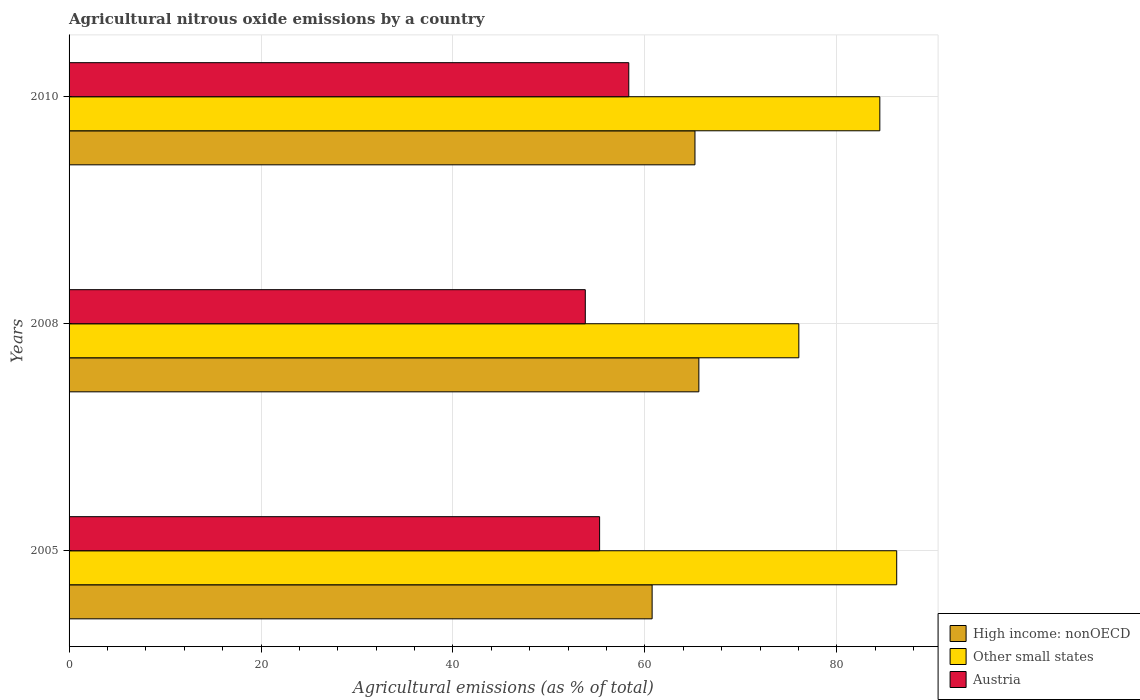How many different coloured bars are there?
Keep it short and to the point. 3. How many groups of bars are there?
Ensure brevity in your answer.  3. Are the number of bars per tick equal to the number of legend labels?
Your answer should be compact. Yes. How many bars are there on the 3rd tick from the top?
Ensure brevity in your answer.  3. How many bars are there on the 2nd tick from the bottom?
Give a very brief answer. 3. What is the label of the 3rd group of bars from the top?
Offer a terse response. 2005. In how many cases, is the number of bars for a given year not equal to the number of legend labels?
Give a very brief answer. 0. What is the amount of agricultural nitrous oxide emitted in Austria in 2008?
Keep it short and to the point. 53.8. Across all years, what is the maximum amount of agricultural nitrous oxide emitted in Other small states?
Your response must be concise. 86.25. Across all years, what is the minimum amount of agricultural nitrous oxide emitted in Austria?
Give a very brief answer. 53.8. In which year was the amount of agricultural nitrous oxide emitted in Other small states maximum?
Your response must be concise. 2005. In which year was the amount of agricultural nitrous oxide emitted in Austria minimum?
Your answer should be compact. 2008. What is the total amount of agricultural nitrous oxide emitted in High income: nonOECD in the graph?
Provide a short and direct response. 191.61. What is the difference between the amount of agricultural nitrous oxide emitted in Other small states in 2008 and that in 2010?
Offer a very short reply. -8.44. What is the difference between the amount of agricultural nitrous oxide emitted in Other small states in 2005 and the amount of agricultural nitrous oxide emitted in High income: nonOECD in 2008?
Offer a very short reply. 20.62. What is the average amount of agricultural nitrous oxide emitted in Austria per year?
Your answer should be very brief. 55.8. In the year 2005, what is the difference between the amount of agricultural nitrous oxide emitted in Austria and amount of agricultural nitrous oxide emitted in Other small states?
Provide a short and direct response. -30.96. In how many years, is the amount of agricultural nitrous oxide emitted in Other small states greater than 20 %?
Offer a terse response. 3. What is the ratio of the amount of agricultural nitrous oxide emitted in Other small states in 2005 to that in 2008?
Offer a very short reply. 1.13. Is the amount of agricultural nitrous oxide emitted in High income: nonOECD in 2008 less than that in 2010?
Offer a terse response. No. Is the difference between the amount of agricultural nitrous oxide emitted in Austria in 2005 and 2010 greater than the difference between the amount of agricultural nitrous oxide emitted in Other small states in 2005 and 2010?
Give a very brief answer. No. What is the difference between the highest and the second highest amount of agricultural nitrous oxide emitted in Other small states?
Keep it short and to the point. 1.76. What is the difference between the highest and the lowest amount of agricultural nitrous oxide emitted in Other small states?
Offer a terse response. 10.2. What does the 3rd bar from the top in 2005 represents?
Give a very brief answer. High income: nonOECD. What does the 2nd bar from the bottom in 2005 represents?
Give a very brief answer. Other small states. Is it the case that in every year, the sum of the amount of agricultural nitrous oxide emitted in Other small states and amount of agricultural nitrous oxide emitted in High income: nonOECD is greater than the amount of agricultural nitrous oxide emitted in Austria?
Make the answer very short. Yes. How many bars are there?
Ensure brevity in your answer.  9. Are all the bars in the graph horizontal?
Keep it short and to the point. Yes. How many years are there in the graph?
Offer a terse response. 3. Does the graph contain any zero values?
Make the answer very short. No. Where does the legend appear in the graph?
Offer a very short reply. Bottom right. How many legend labels are there?
Ensure brevity in your answer.  3. What is the title of the graph?
Offer a very short reply. Agricultural nitrous oxide emissions by a country. What is the label or title of the X-axis?
Provide a short and direct response. Agricultural emissions (as % of total). What is the Agricultural emissions (as % of total) in High income: nonOECD in 2005?
Your response must be concise. 60.76. What is the Agricultural emissions (as % of total) in Other small states in 2005?
Ensure brevity in your answer.  86.25. What is the Agricultural emissions (as % of total) in Austria in 2005?
Your answer should be compact. 55.29. What is the Agricultural emissions (as % of total) in High income: nonOECD in 2008?
Your answer should be compact. 65.63. What is the Agricultural emissions (as % of total) of Other small states in 2008?
Your response must be concise. 76.05. What is the Agricultural emissions (as % of total) of Austria in 2008?
Ensure brevity in your answer.  53.8. What is the Agricultural emissions (as % of total) in High income: nonOECD in 2010?
Offer a terse response. 65.22. What is the Agricultural emissions (as % of total) of Other small states in 2010?
Your answer should be compact. 84.49. What is the Agricultural emissions (as % of total) of Austria in 2010?
Ensure brevity in your answer.  58.33. Across all years, what is the maximum Agricultural emissions (as % of total) of High income: nonOECD?
Offer a terse response. 65.63. Across all years, what is the maximum Agricultural emissions (as % of total) in Other small states?
Keep it short and to the point. 86.25. Across all years, what is the maximum Agricultural emissions (as % of total) of Austria?
Make the answer very short. 58.33. Across all years, what is the minimum Agricultural emissions (as % of total) of High income: nonOECD?
Offer a very short reply. 60.76. Across all years, what is the minimum Agricultural emissions (as % of total) of Other small states?
Make the answer very short. 76.05. Across all years, what is the minimum Agricultural emissions (as % of total) in Austria?
Offer a very short reply. 53.8. What is the total Agricultural emissions (as % of total) of High income: nonOECD in the graph?
Provide a short and direct response. 191.61. What is the total Agricultural emissions (as % of total) in Other small states in the graph?
Offer a terse response. 246.78. What is the total Agricultural emissions (as % of total) in Austria in the graph?
Give a very brief answer. 167.41. What is the difference between the Agricultural emissions (as % of total) of High income: nonOECD in 2005 and that in 2008?
Your answer should be very brief. -4.87. What is the difference between the Agricultural emissions (as % of total) of Other small states in 2005 and that in 2008?
Give a very brief answer. 10.2. What is the difference between the Agricultural emissions (as % of total) of Austria in 2005 and that in 2008?
Provide a succinct answer. 1.49. What is the difference between the Agricultural emissions (as % of total) in High income: nonOECD in 2005 and that in 2010?
Keep it short and to the point. -4.47. What is the difference between the Agricultural emissions (as % of total) in Other small states in 2005 and that in 2010?
Keep it short and to the point. 1.76. What is the difference between the Agricultural emissions (as % of total) in Austria in 2005 and that in 2010?
Ensure brevity in your answer.  -3.04. What is the difference between the Agricultural emissions (as % of total) in High income: nonOECD in 2008 and that in 2010?
Offer a very short reply. 0.4. What is the difference between the Agricultural emissions (as % of total) of Other small states in 2008 and that in 2010?
Your answer should be compact. -8.44. What is the difference between the Agricultural emissions (as % of total) in Austria in 2008 and that in 2010?
Make the answer very short. -4.53. What is the difference between the Agricultural emissions (as % of total) of High income: nonOECD in 2005 and the Agricultural emissions (as % of total) of Other small states in 2008?
Keep it short and to the point. -15.29. What is the difference between the Agricultural emissions (as % of total) of High income: nonOECD in 2005 and the Agricultural emissions (as % of total) of Austria in 2008?
Your answer should be very brief. 6.96. What is the difference between the Agricultural emissions (as % of total) of Other small states in 2005 and the Agricultural emissions (as % of total) of Austria in 2008?
Your answer should be very brief. 32.45. What is the difference between the Agricultural emissions (as % of total) of High income: nonOECD in 2005 and the Agricultural emissions (as % of total) of Other small states in 2010?
Your answer should be compact. -23.73. What is the difference between the Agricultural emissions (as % of total) in High income: nonOECD in 2005 and the Agricultural emissions (as % of total) in Austria in 2010?
Your response must be concise. 2.43. What is the difference between the Agricultural emissions (as % of total) of Other small states in 2005 and the Agricultural emissions (as % of total) of Austria in 2010?
Provide a short and direct response. 27.92. What is the difference between the Agricultural emissions (as % of total) of High income: nonOECD in 2008 and the Agricultural emissions (as % of total) of Other small states in 2010?
Your answer should be compact. -18.86. What is the difference between the Agricultural emissions (as % of total) in High income: nonOECD in 2008 and the Agricultural emissions (as % of total) in Austria in 2010?
Your response must be concise. 7.3. What is the difference between the Agricultural emissions (as % of total) in Other small states in 2008 and the Agricultural emissions (as % of total) in Austria in 2010?
Offer a terse response. 17.72. What is the average Agricultural emissions (as % of total) of High income: nonOECD per year?
Offer a very short reply. 63.87. What is the average Agricultural emissions (as % of total) in Other small states per year?
Your answer should be compact. 82.26. What is the average Agricultural emissions (as % of total) of Austria per year?
Your response must be concise. 55.8. In the year 2005, what is the difference between the Agricultural emissions (as % of total) of High income: nonOECD and Agricultural emissions (as % of total) of Other small states?
Keep it short and to the point. -25.49. In the year 2005, what is the difference between the Agricultural emissions (as % of total) in High income: nonOECD and Agricultural emissions (as % of total) in Austria?
Provide a succinct answer. 5.47. In the year 2005, what is the difference between the Agricultural emissions (as % of total) in Other small states and Agricultural emissions (as % of total) in Austria?
Your answer should be compact. 30.96. In the year 2008, what is the difference between the Agricultural emissions (as % of total) in High income: nonOECD and Agricultural emissions (as % of total) in Other small states?
Your answer should be very brief. -10.42. In the year 2008, what is the difference between the Agricultural emissions (as % of total) of High income: nonOECD and Agricultural emissions (as % of total) of Austria?
Your response must be concise. 11.83. In the year 2008, what is the difference between the Agricultural emissions (as % of total) in Other small states and Agricultural emissions (as % of total) in Austria?
Your answer should be very brief. 22.25. In the year 2010, what is the difference between the Agricultural emissions (as % of total) of High income: nonOECD and Agricultural emissions (as % of total) of Other small states?
Give a very brief answer. -19.26. In the year 2010, what is the difference between the Agricultural emissions (as % of total) in High income: nonOECD and Agricultural emissions (as % of total) in Austria?
Offer a terse response. 6.9. In the year 2010, what is the difference between the Agricultural emissions (as % of total) in Other small states and Agricultural emissions (as % of total) in Austria?
Offer a very short reply. 26.16. What is the ratio of the Agricultural emissions (as % of total) in High income: nonOECD in 2005 to that in 2008?
Offer a very short reply. 0.93. What is the ratio of the Agricultural emissions (as % of total) in Other small states in 2005 to that in 2008?
Your response must be concise. 1.13. What is the ratio of the Agricultural emissions (as % of total) of Austria in 2005 to that in 2008?
Offer a terse response. 1.03. What is the ratio of the Agricultural emissions (as % of total) of High income: nonOECD in 2005 to that in 2010?
Offer a terse response. 0.93. What is the ratio of the Agricultural emissions (as % of total) of Other small states in 2005 to that in 2010?
Offer a terse response. 1.02. What is the ratio of the Agricultural emissions (as % of total) in Austria in 2005 to that in 2010?
Your answer should be compact. 0.95. What is the ratio of the Agricultural emissions (as % of total) in Other small states in 2008 to that in 2010?
Your answer should be compact. 0.9. What is the ratio of the Agricultural emissions (as % of total) of Austria in 2008 to that in 2010?
Ensure brevity in your answer.  0.92. What is the difference between the highest and the second highest Agricultural emissions (as % of total) in High income: nonOECD?
Ensure brevity in your answer.  0.4. What is the difference between the highest and the second highest Agricultural emissions (as % of total) in Other small states?
Provide a short and direct response. 1.76. What is the difference between the highest and the second highest Agricultural emissions (as % of total) in Austria?
Make the answer very short. 3.04. What is the difference between the highest and the lowest Agricultural emissions (as % of total) of High income: nonOECD?
Provide a succinct answer. 4.87. What is the difference between the highest and the lowest Agricultural emissions (as % of total) in Other small states?
Provide a succinct answer. 10.2. What is the difference between the highest and the lowest Agricultural emissions (as % of total) of Austria?
Give a very brief answer. 4.53. 